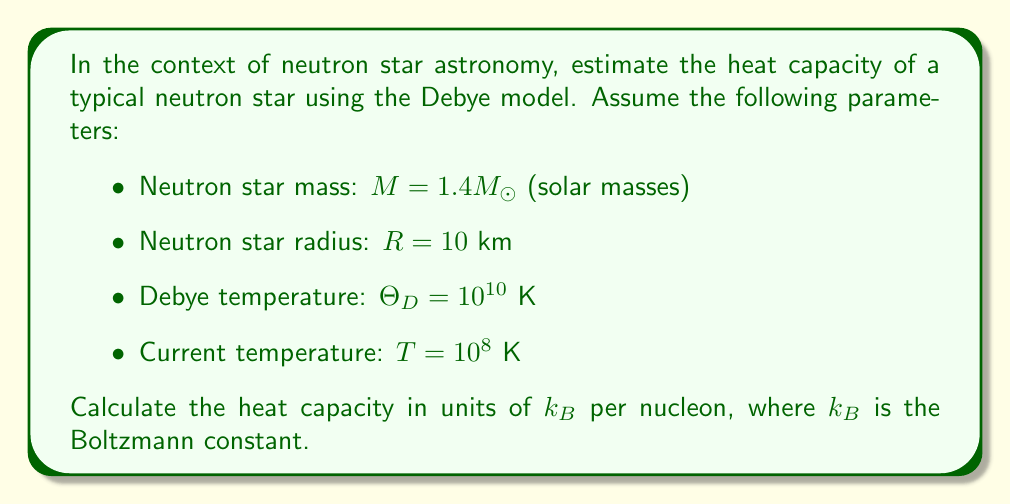Teach me how to tackle this problem. To estimate the heat capacity of a neutron star using the Debye model, we'll follow these steps:

1) The Debye model for heat capacity at low temperatures (T << Θ_D) is given by:

   $$C_V = \frac{12\pi^4}{5} N k_B \left(\frac{T}{\Theta_D}\right)^3$$

   where N is the number of particles.

2) First, let's calculate the number of nucleons in the neutron star:
   
   $$N = \frac{M}{m_n} = \frac{1.4M_\odot}{m_n}$$
   
   where $m_n$ is the mass of a nucleon (approximately $1.67 \times 10^{-27}$ kg).

3) Now, we can substitute the given values into the Debye heat capacity formula:

   $$C_V = \frac{12\pi^4}{5} \frac{1.4M_\odot}{m_n} k_B \left(\frac{10^8}{10^{10}}\right)^3$$

4) Simplify:

   $$C_V = \frac{12\pi^4}{5} \frac{1.4M_\odot}{m_n} k_B \times 10^{-6}$$

5) To express this in units of $k_B$ per nucleon, we divide by $Nk_B$:

   $$\frac{C_V}{Nk_B} = \frac{12\pi^4}{5} \times 10^{-6} \approx 7.6 \times 10^{-5}$$
Answer: $7.6 \times 10^{-5} k_B$ per nucleon 